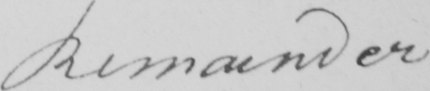Can you tell me what this handwritten text says? Remainder 